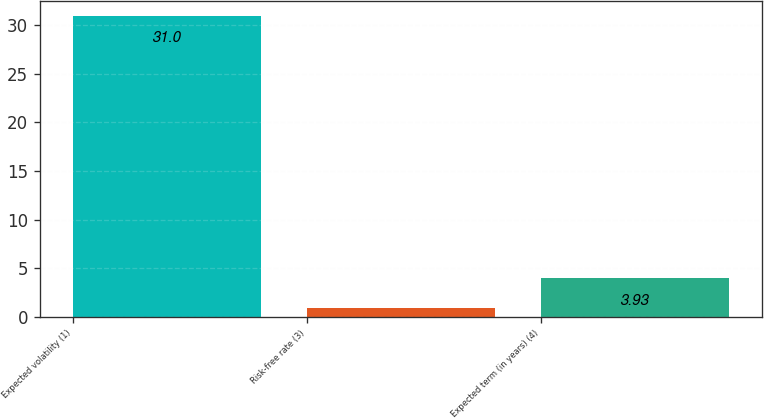<chart> <loc_0><loc_0><loc_500><loc_500><bar_chart><fcel>Expected volatility (1)<fcel>Risk-free rate (3)<fcel>Expected term (in years) (4)<nl><fcel>31<fcel>0.92<fcel>3.93<nl></chart> 